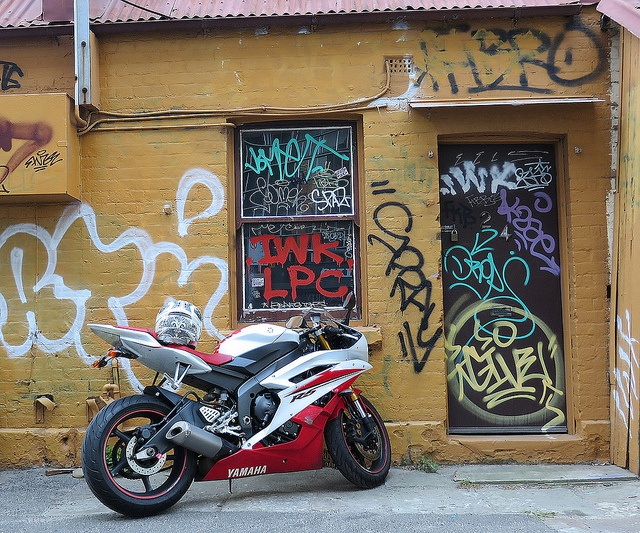Describe the objects in this image and their specific colors. I can see a motorcycle in pink, black, white, gray, and maroon tones in this image. 